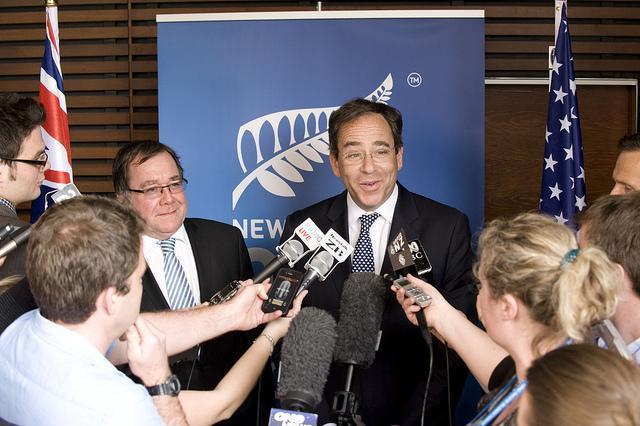Why are the people holding microphones?
From the following set of four choices, select the accurate answer to respond to the question.
Options: To sing, to announce, for karaoke, to interview. To interview. 